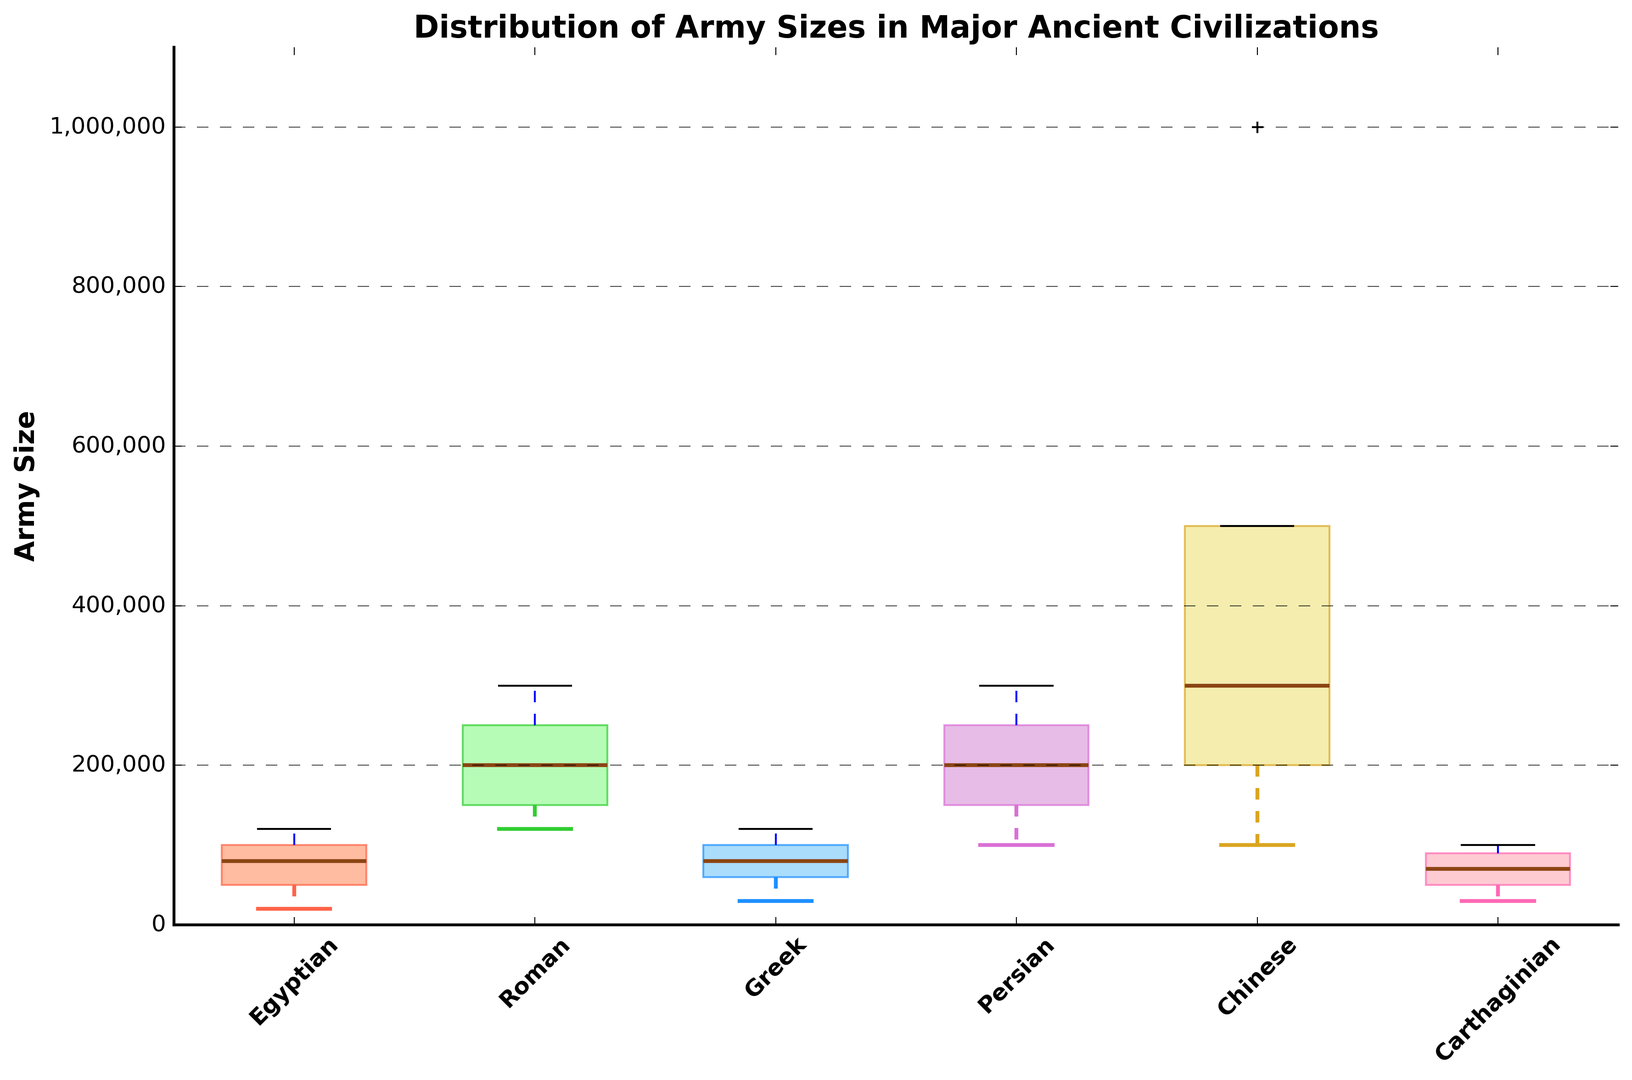Which civilization has the highest median army size? The box plot shows the median value as a line within the box. The Chinese civilization has the highest median, which is higher than the medians of the other civilizations.
Answer: Chinese Between the Roman and Greek civilizations, which has a larger range of army sizes? The range is the difference between the maximum and minimum values. The Romans have a range from around 120,000 to 300,000, while the Greeks range from around 30,000 to 120,000. The Roman range is larger.
Answer: Roman What is the interquartile range (IQR) for the Egyptian civilization's army sizes? The IQR is the difference between the third quartile (Q3) and the first quartile (Q1). For the Egyptians, Q3 is around 100,000 and Q1 is around 50,000, so the IQR is 100,000 - 50,000 = 50,000.
Answer: 50,000 Which civilization has the smallest minimum army size and what is it? The minimum value is represented by the lower whisker. The Greek civilization has the smallest minimum army size, which is around 30,000.
Answer: Greek, 30,000 How does the median army size of the Carthaginians compare to that of the Egyptians? The median is the line inside each box. The Carthaginian median is around 70,000 while the Egyptian median is around 80,000. The Egyptian median is larger.
Answer: Egyptian is larger Which civilization has the widest interquartile range (IQR) for army sizes? The IQR is the width of the box in the box plot. The Chinese civilization has the widest IQR because its box is the largest.
Answer: Chinese Between Persian and Roman civilizations, which has a higher maximum army size? The maximum value is represented by the upper whisker. The Persians have a maximum army size of 300,000, which is the same as the Romans.
Answer: Equal Taking the Greek, Roman, and Egyptian civilizations, which has the highest outlier, if any? Outliers are typically represented by dots outside the whiskers. The Chinese civilization has a distinct dot at 1,000,000, which is significantly higher than the maximum values of the Greek, Roman, and Egyptian civilizations.
Answer: None in Greek, Roman, Egyptian What is the overall trend in army sizes comparing western (Greek, Roman, Carthaginian) and eastern (Chinese, Persian, Egyptian) civilizations? The overall trend can be seen by comparing the general heights of the boxes. Eastern civilizations like Chinese have higher army sizes overall, as seen by the higher medians, maxima, and general ranges compared to western civilizations like Greek and Carthaginian.
Answer: Eastern civilizations have larger army sizes 